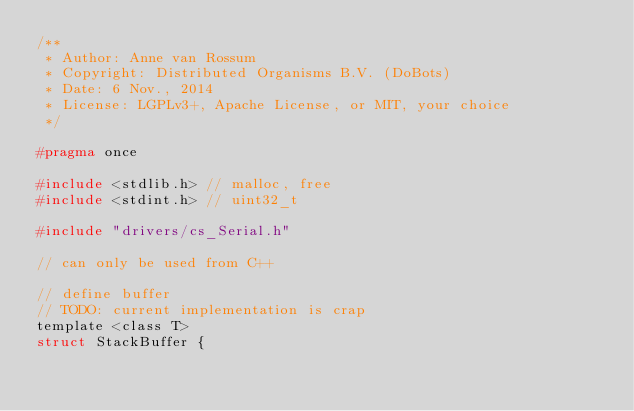Convert code to text. <code><loc_0><loc_0><loc_500><loc_500><_C_>/**
 * Author: Anne van Rossum
 * Copyright: Distributed Organisms B.V. (DoBots)
 * Date: 6 Nov., 2014
 * License: LGPLv3+, Apache License, or MIT, your choice
 */

#pragma once

#include <stdlib.h> // malloc, free
#include <stdint.h> // uint32_t

#include "drivers/cs_Serial.h"

// can only be used from C++

// define buffer
// TODO: current implementation is crap
template <class T>
struct StackBuffer {</code> 